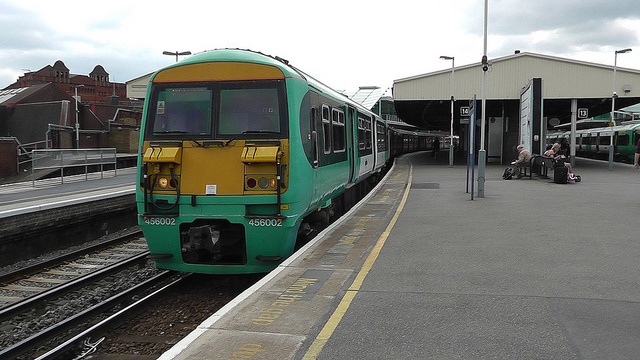Identify the text displayed in this image. 458002 4560 02 